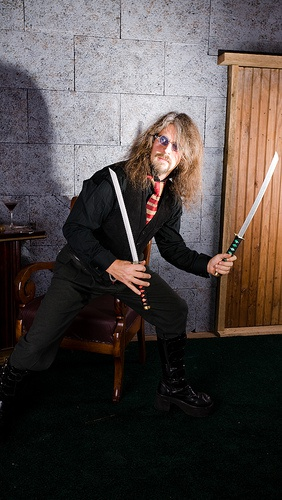Describe the objects in this image and their specific colors. I can see people in gray, black, tan, and brown tones, chair in gray, black, and maroon tones, knife in gray, lightgray, black, and salmon tones, knife in gray, lightgray, black, darkgray, and tan tones, and tie in gray, brown, salmon, and black tones in this image. 